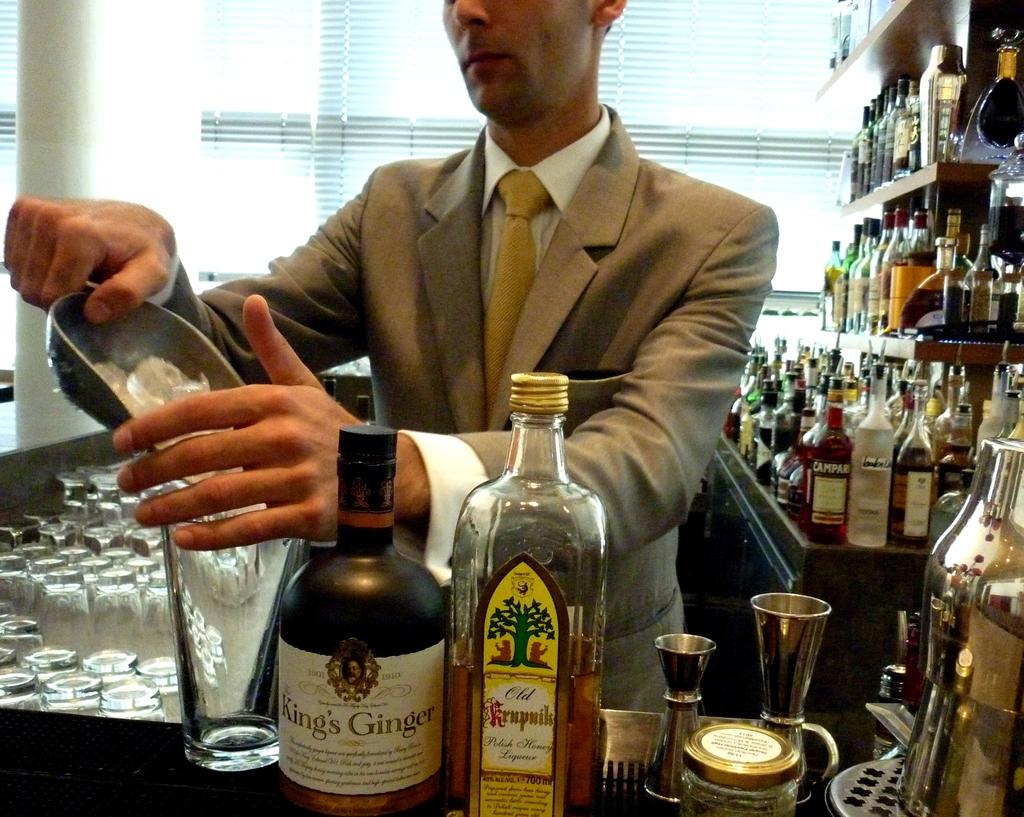Who or what is present in the image? There is a person in the image. What is the person wearing? The person is wearing a suit. What is the person doing or standing near in the image? The person is standing behind bottles. What type of key is the person holding in the image? There is no key present in the image; the person is standing behind bottles. 